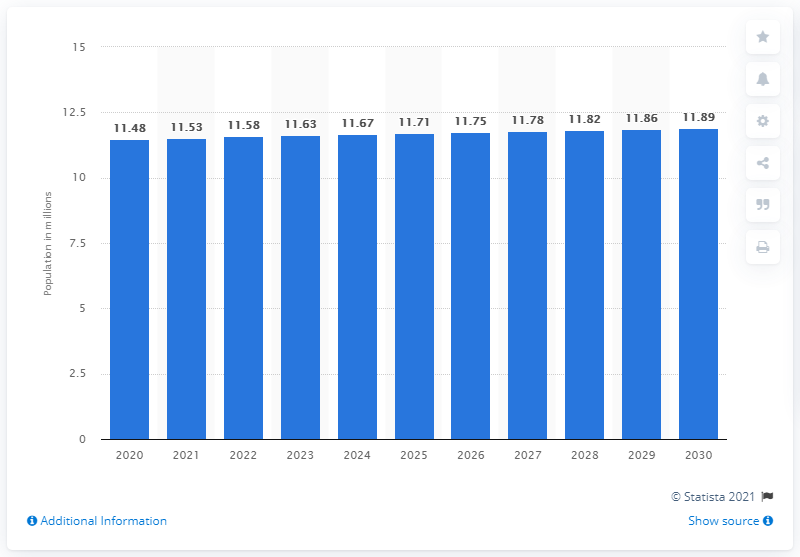Outline some significant characteristics in this image. According to the information available, the population of Belgium in 2020 was 11.58 million. By 2030, the population of Belgium is projected to reach 11.89 million. 